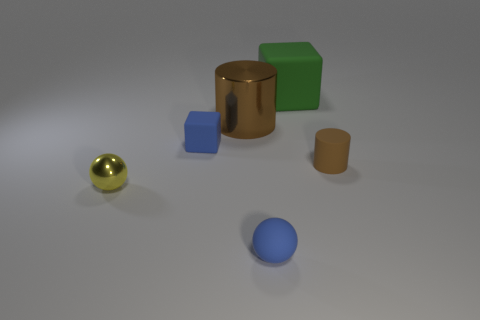Add 2 blue matte spheres. How many objects exist? 8 Subtract all green blocks. How many blocks are left? 1 Subtract 0 yellow cylinders. How many objects are left? 6 Subtract all cubes. How many objects are left? 4 Subtract all blue spheres. Subtract all purple cylinders. How many spheres are left? 1 Subtract all tiny cyan metal cubes. Subtract all tiny matte objects. How many objects are left? 3 Add 6 yellow balls. How many yellow balls are left? 7 Add 3 big yellow shiny balls. How many big yellow shiny balls exist? 3 